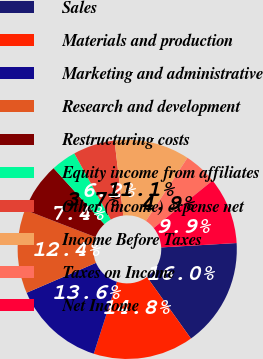<chart> <loc_0><loc_0><loc_500><loc_500><pie_chart><fcel>Sales<fcel>Materials and production<fcel>Marketing and administrative<fcel>Research and development<fcel>Restructuring costs<fcel>Equity income from affiliates<fcel>Other (income) expense net<fcel>Income Before Taxes<fcel>Taxes on Income<fcel>Net Income<nl><fcel>16.05%<fcel>14.81%<fcel>13.58%<fcel>12.35%<fcel>7.41%<fcel>3.7%<fcel>6.17%<fcel>11.11%<fcel>4.94%<fcel>9.88%<nl></chart> 